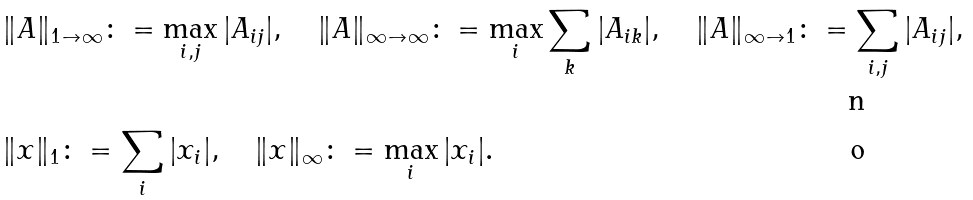Convert formula to latex. <formula><loc_0><loc_0><loc_500><loc_500>& \| A \| _ { 1 \to \infty } \colon = \max _ { i , j } | A _ { i j } | , \quad \| A \| _ { \infty \to \infty } \colon = \max _ { i } \sum _ { k } | A _ { i k } | , \quad \| A \| _ { \infty \to 1 } \colon = \sum _ { i , j } | A _ { i j } | , \\ & \| x \| _ { 1 } \colon = \sum _ { i } | x _ { i } | , \quad \| x \| _ { \infty } \colon = \max _ { i } | x _ { i } | .</formula> 